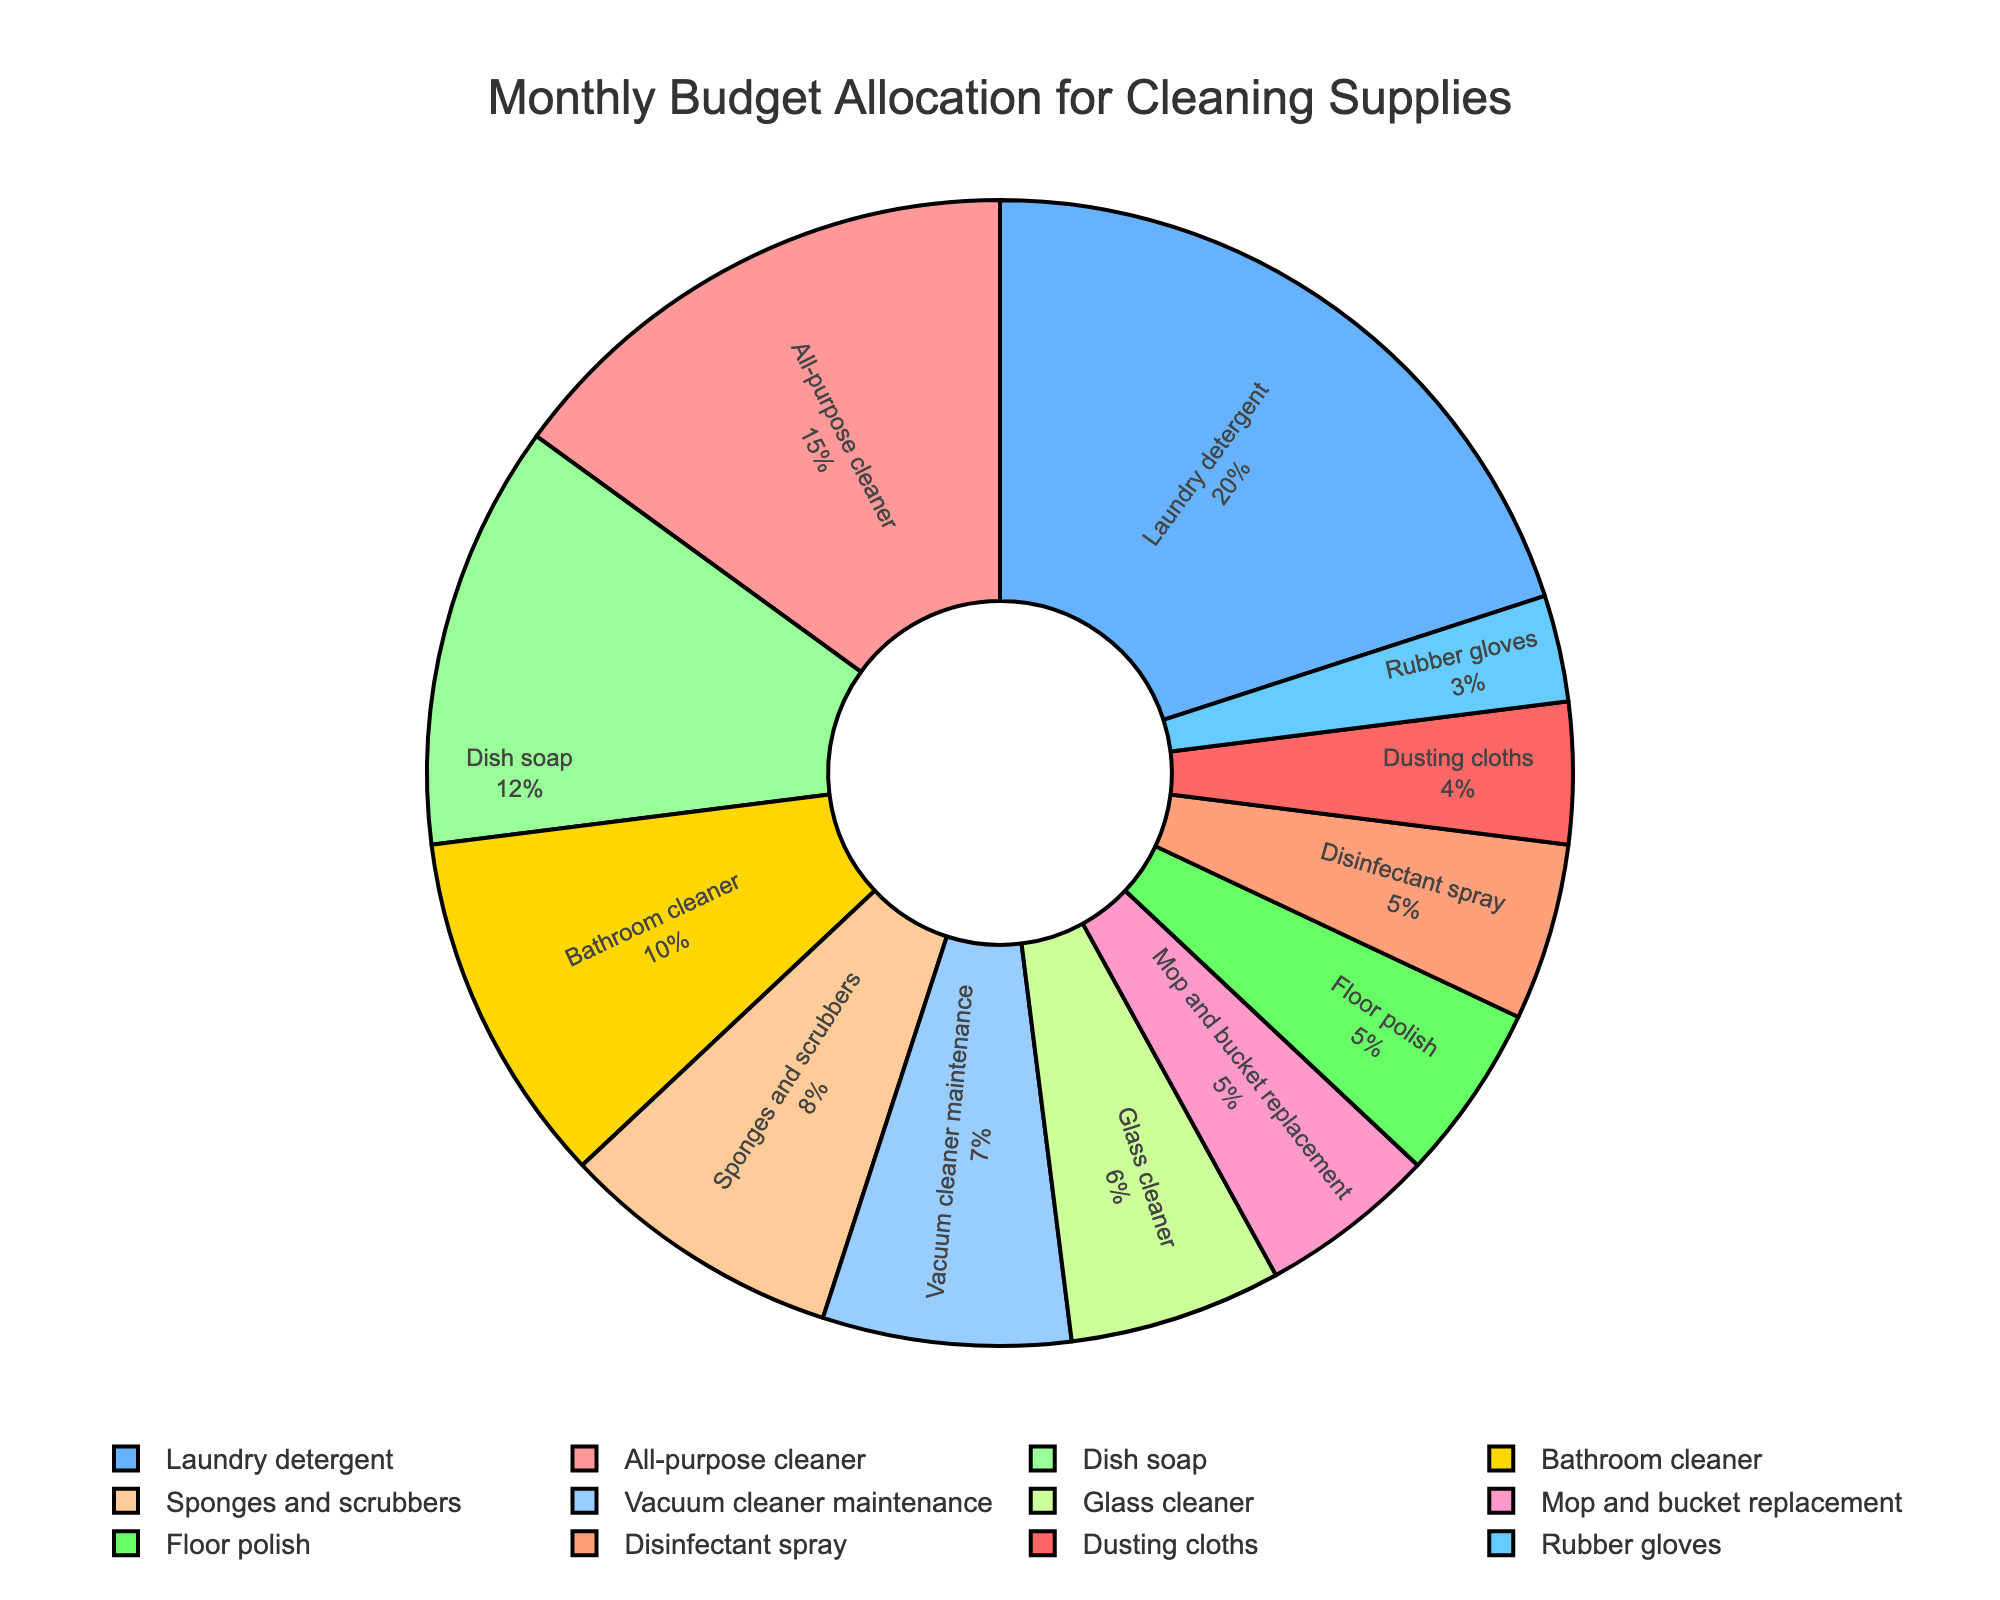What's the largest budget category, and what percentage it represents? The largest category can be identified by comparing each slice's size and percentage label on the pie chart. The slice for Laundry detergent appears to be the largest.
Answer: Laundry detergent, 20% If the budget for Mop and bucket replacement were increased by 3%, which category would it equal in percentage? Increase the Mop and bucket replacement budget from 5% to 8%. The category that also has a budget of 8% is Sponges and scrubbers.
Answer: Sponges and scrubbers How much more is allocated to Dish soap compared to Rubber gloves? Subtract the percentage of Rubber gloves (3%) from Dish soap (12%). The difference is 12% - 3% = 9%.
Answer: 9% What is the combined budget allocation for All-purpose cleaner, Bathroom cleaner, and Disinfectant spray? Add the percentages of All-purpose cleaner (15%), Bathroom cleaner (10%), and Disinfectant spray (5%). The total is 15% + 10% + 5% = 30%.
Answer: 30% Which two categories have the closest budget allocation, and what are their percentages? Compare the percentages of all categories to find the closest values. The closest are Floor polish (5%) and Disinfectant spray (5%).
Answer: Floor polish and Disinfectant spray, both 5% How does the budget for Vacuum cleaner maintenance compare to that for Glass cleaner? Compare the percentages directly from the pie chart. Vacuum cleaner maintenance is 7% and Glass cleaner is 6%.
Answer: Vacuum cleaner maintenance is 1% higher Which category has a budget allocation represented by a yellow slice? Identify the yellow slice visually from the pie chart. This yellow slice corresponds to Dusting cloths.
Answer: Dusting cloths What is the total budget allocation for categories related to 'cleaner'? Add the percentages of All-purpose cleaner (15%), Glass cleaner (6%), Bathroom cleaner (10%), and Floor polish (5%). The total is 15% + 6% + 10% + 5% = 36%.
Answer: 36% If the total budget is $500, how much money is allocated to the Dish soap category? Calculate 12% of $500 by multiplying 0.12 by 500. The amount is 0.12 * 500 = $60.
Answer: $60 